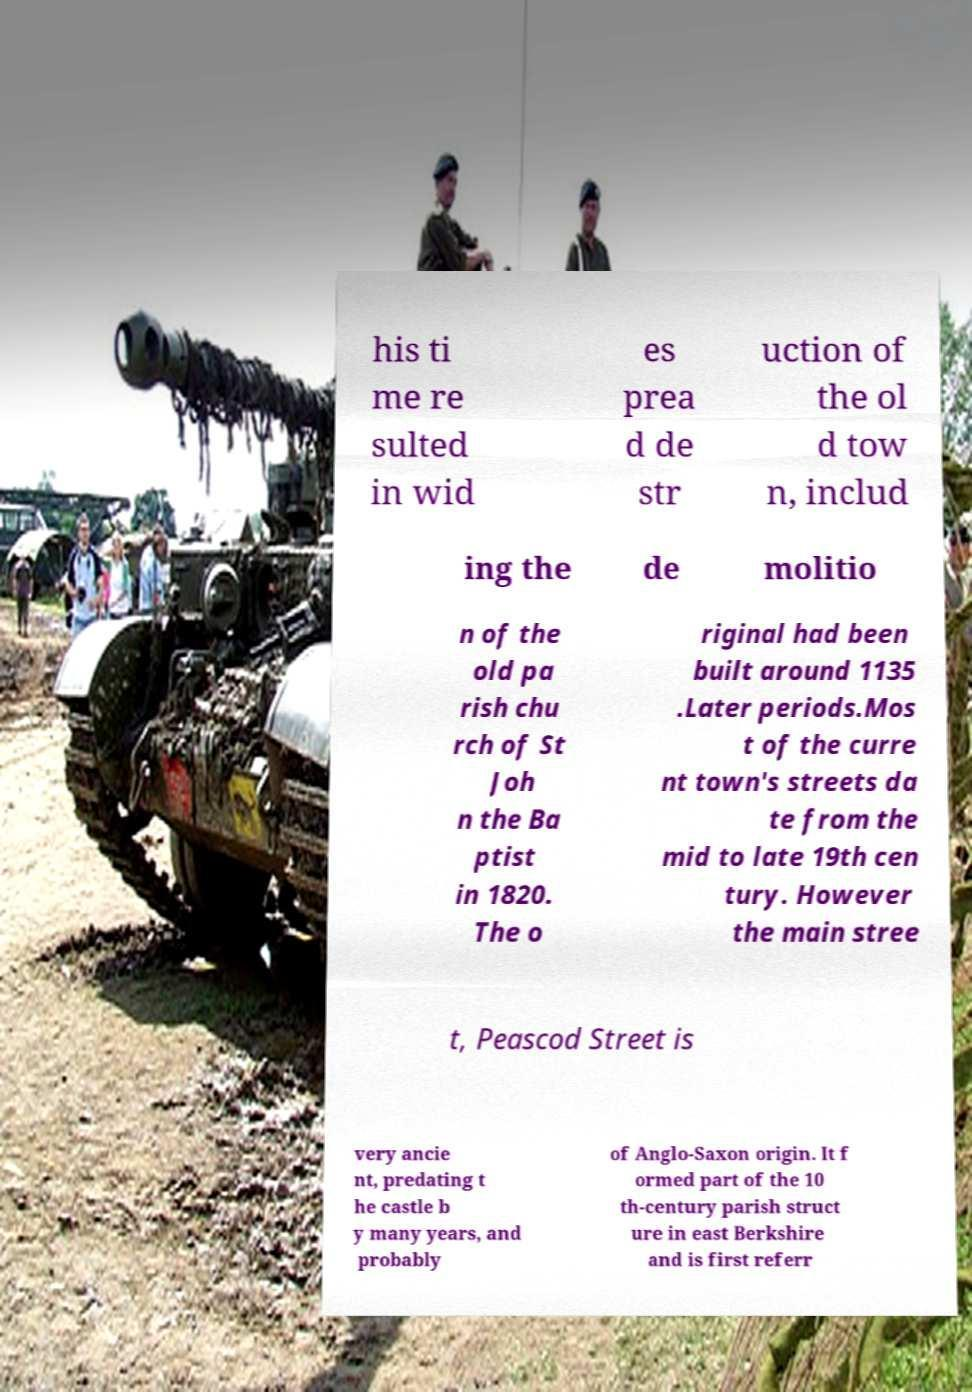Can you accurately transcribe the text from the provided image for me? his ti me re sulted in wid es prea d de str uction of the ol d tow n, includ ing the de molitio n of the old pa rish chu rch of St Joh n the Ba ptist in 1820. The o riginal had been built around 1135 .Later periods.Mos t of the curre nt town's streets da te from the mid to late 19th cen tury. However the main stree t, Peascod Street is very ancie nt, predating t he castle b y many years, and probably of Anglo-Saxon origin. It f ormed part of the 10 th-century parish struct ure in east Berkshire and is first referr 